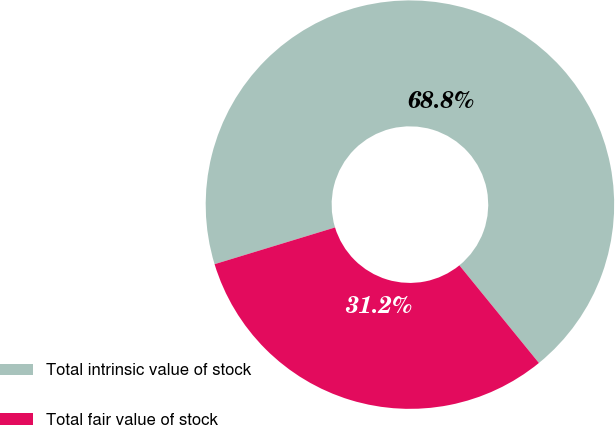<chart> <loc_0><loc_0><loc_500><loc_500><pie_chart><fcel>Total intrinsic value of stock<fcel>Total fair value of stock<nl><fcel>68.83%<fcel>31.17%<nl></chart> 